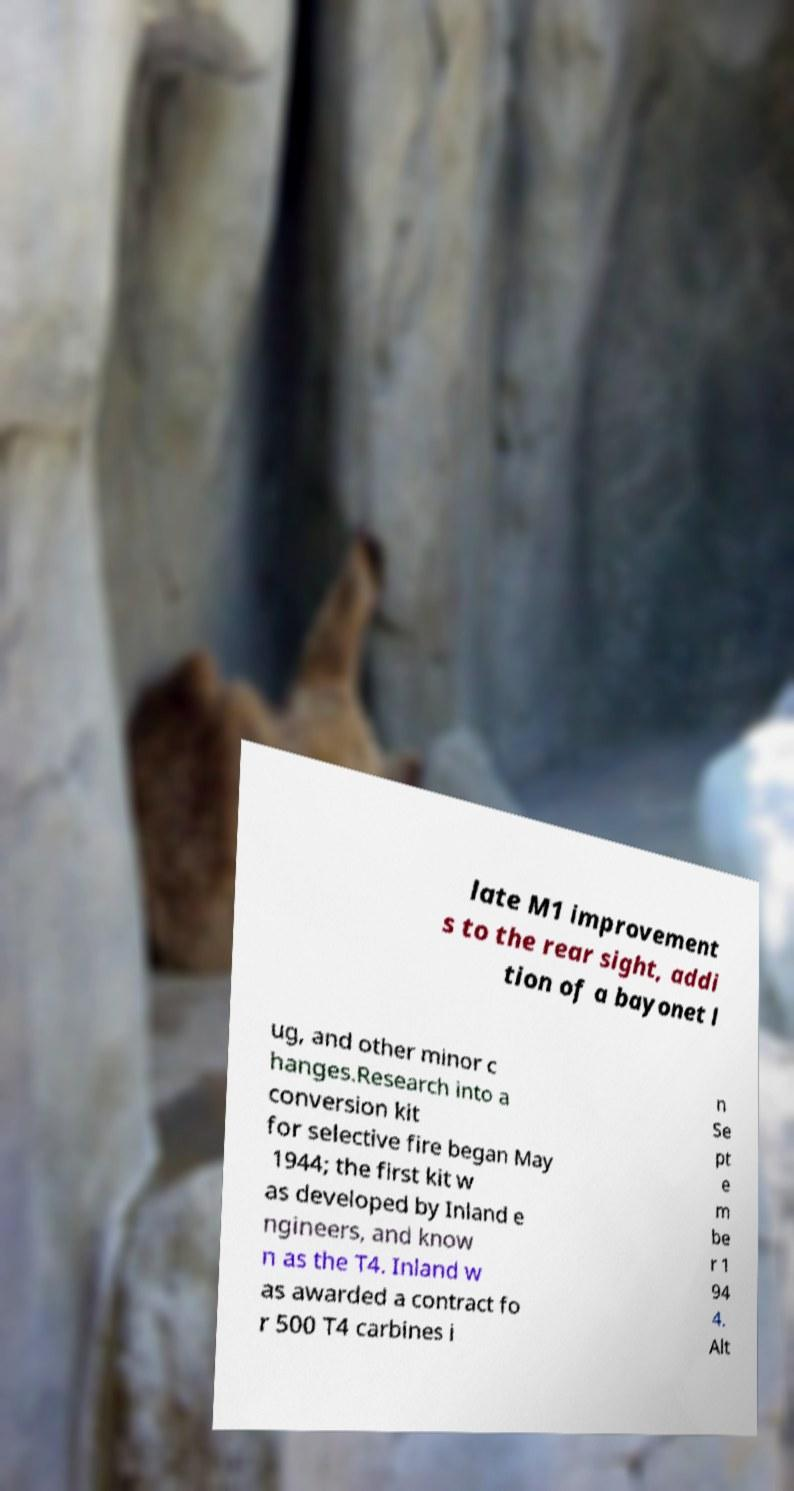What messages or text are displayed in this image? I need them in a readable, typed format. late M1 improvement s to the rear sight, addi tion of a bayonet l ug, and other minor c hanges.Research into a conversion kit for selective fire began May 1944; the first kit w as developed by Inland e ngineers, and know n as the T4. Inland w as awarded a contract fo r 500 T4 carbines i n Se pt e m be r 1 94 4. Alt 